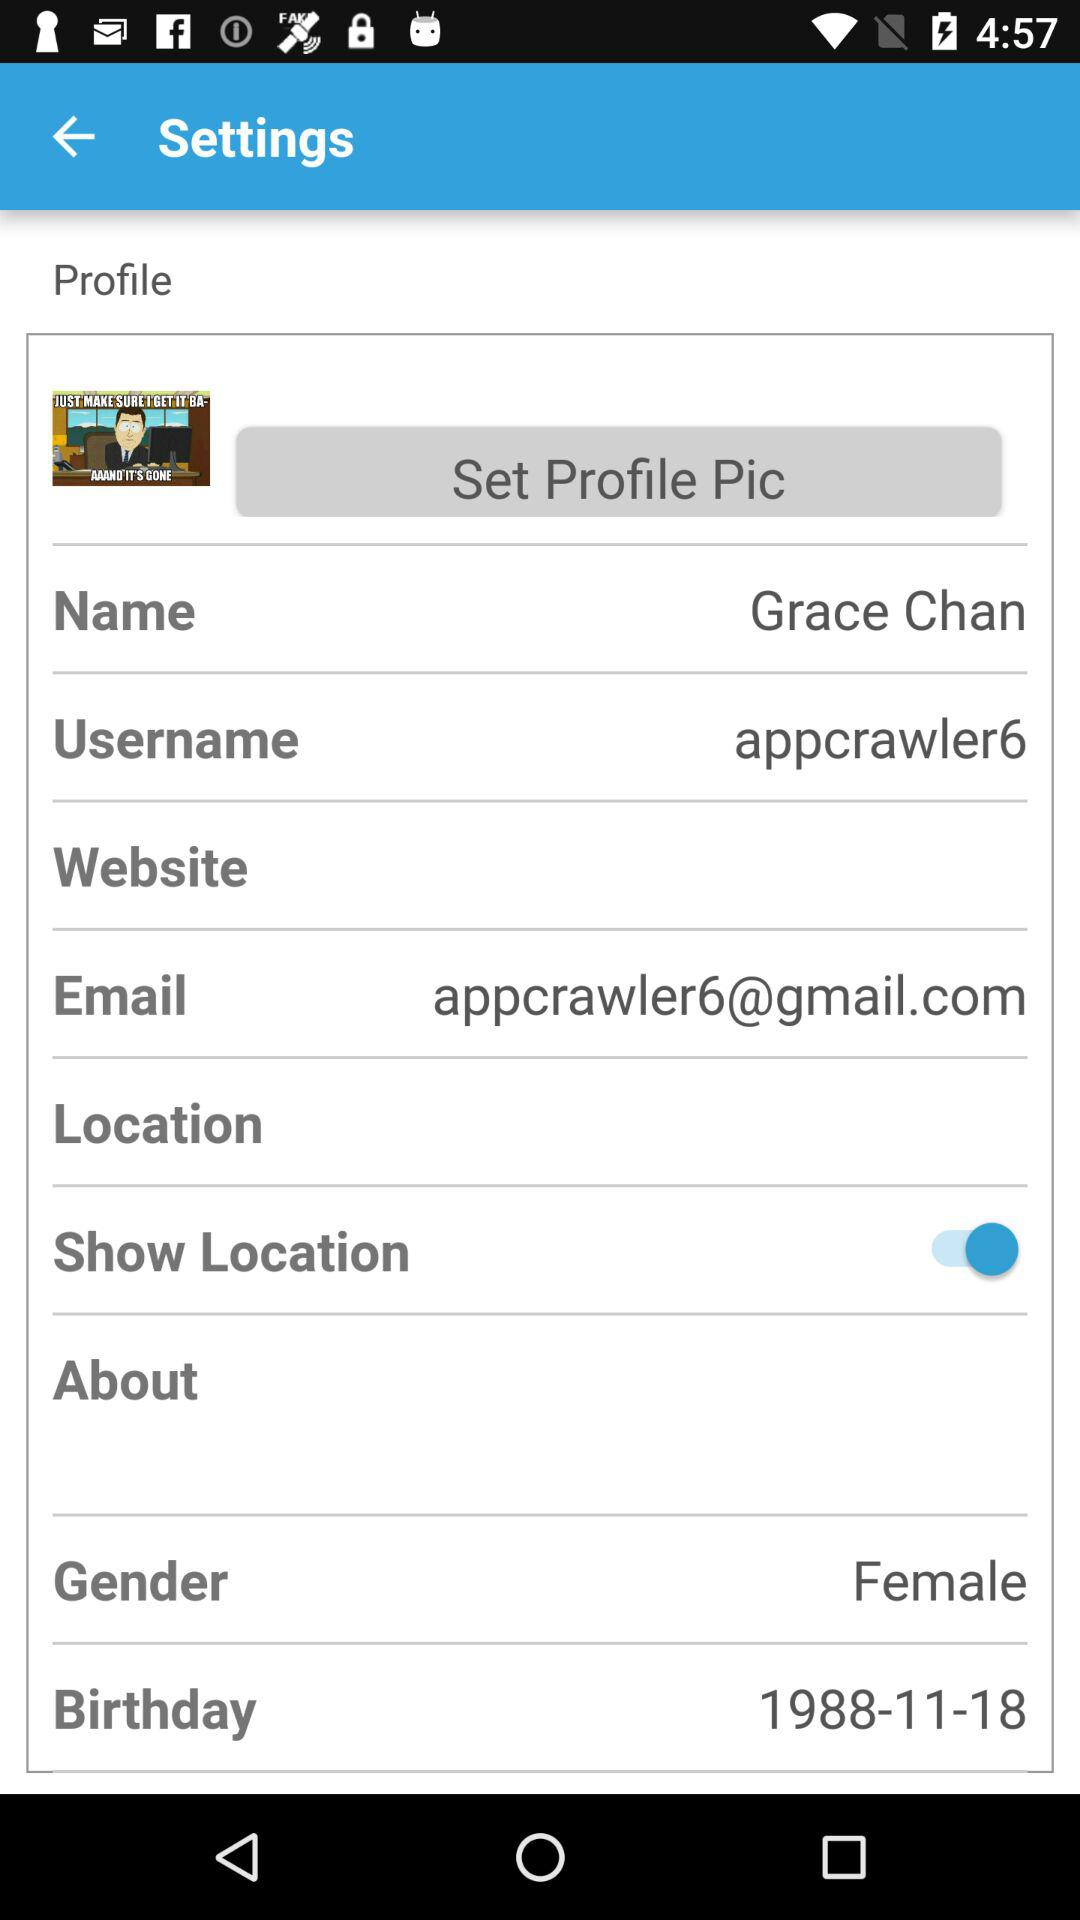What is the date of birth? The date of birth is November 18, 1988. 